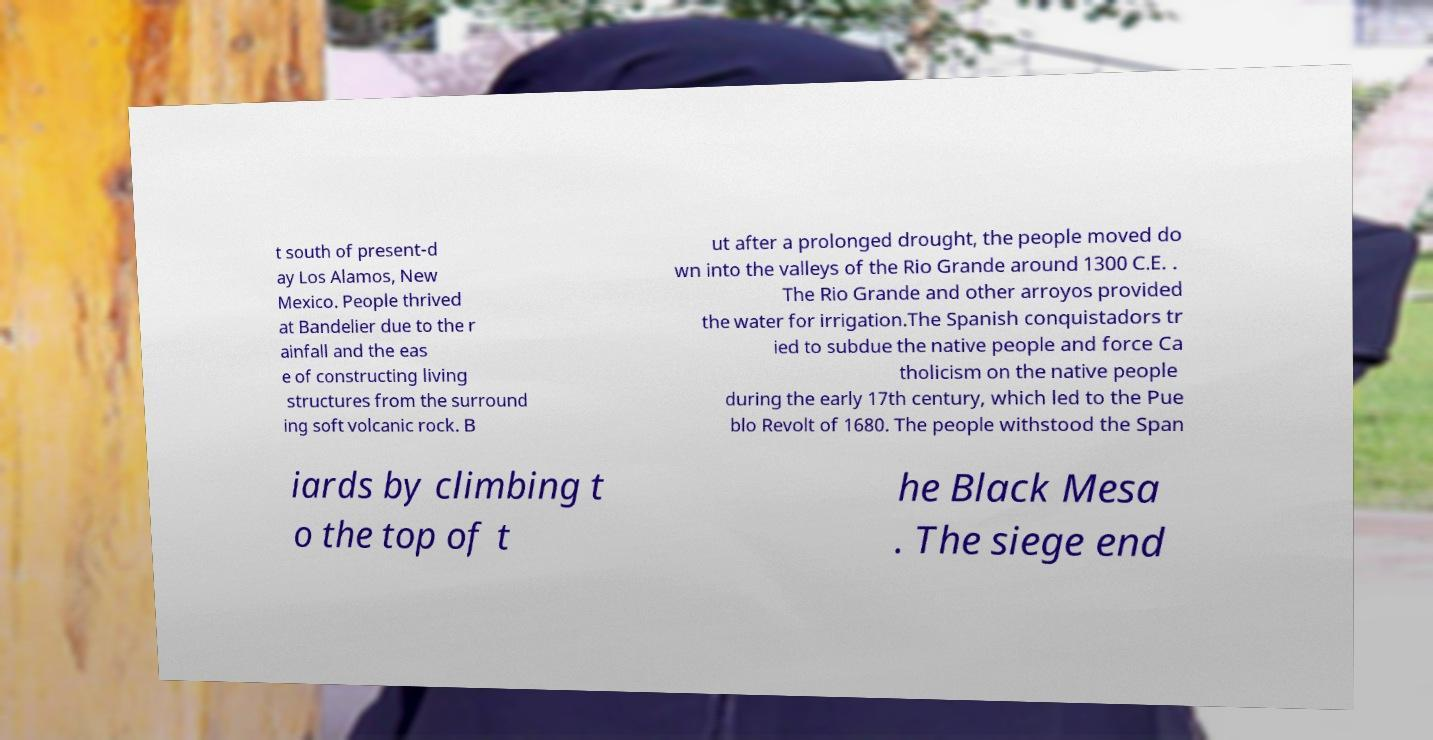Please read and relay the text visible in this image. What does it say? t south of present-d ay Los Alamos, New Mexico. People thrived at Bandelier due to the r ainfall and the eas e of constructing living structures from the surround ing soft volcanic rock. B ut after a prolonged drought, the people moved do wn into the valleys of the Rio Grande around 1300 C.E. . The Rio Grande and other arroyos provided the water for irrigation.The Spanish conquistadors tr ied to subdue the native people and force Ca tholicism on the native people during the early 17th century, which led to the Pue blo Revolt of 1680. The people withstood the Span iards by climbing t o the top of t he Black Mesa . The siege end 